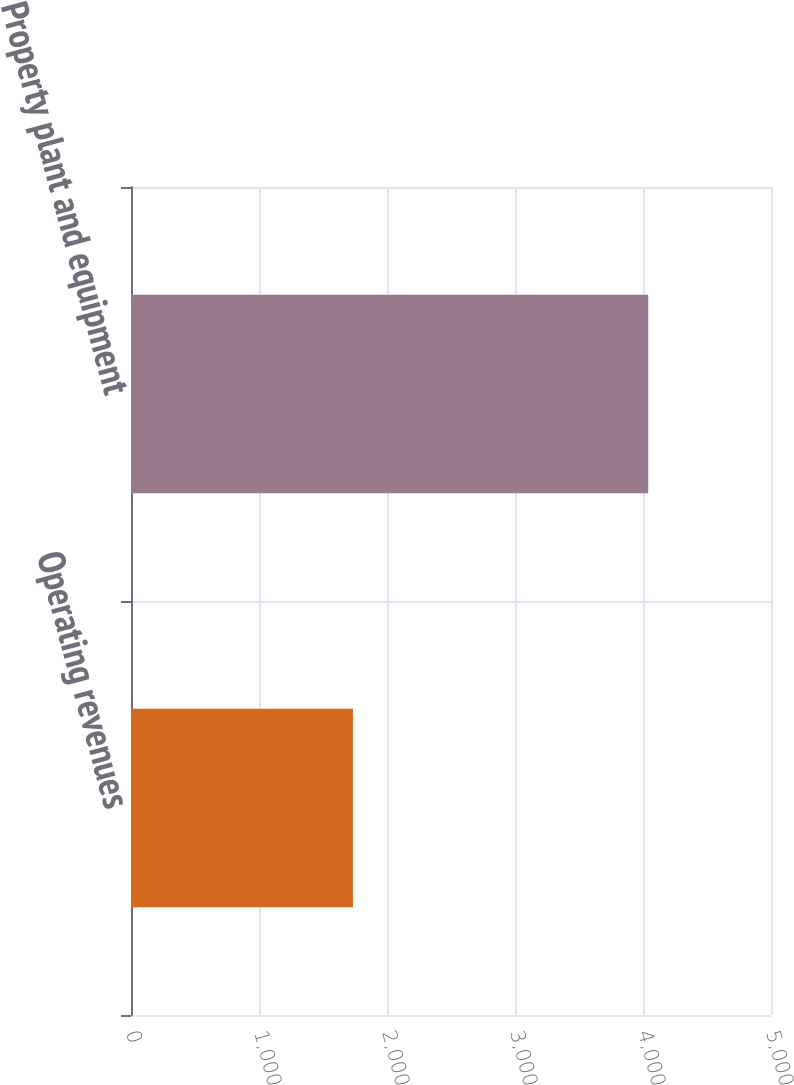<chart> <loc_0><loc_0><loc_500><loc_500><bar_chart><fcel>Operating revenues<fcel>Property plant and equipment<nl><fcel>1734<fcel>4041<nl></chart> 